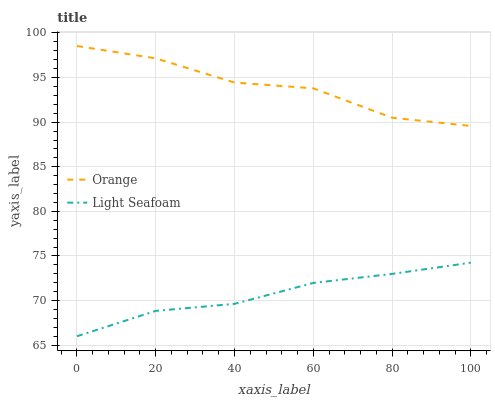Does Light Seafoam have the minimum area under the curve?
Answer yes or no. Yes. Does Orange have the maximum area under the curve?
Answer yes or no. Yes. Does Light Seafoam have the maximum area under the curve?
Answer yes or no. No. Is Light Seafoam the smoothest?
Answer yes or no. Yes. Is Orange the roughest?
Answer yes or no. Yes. Is Light Seafoam the roughest?
Answer yes or no. No. Does Light Seafoam have the lowest value?
Answer yes or no. Yes. Does Orange have the highest value?
Answer yes or no. Yes. Does Light Seafoam have the highest value?
Answer yes or no. No. Is Light Seafoam less than Orange?
Answer yes or no. Yes. Is Orange greater than Light Seafoam?
Answer yes or no. Yes. Does Light Seafoam intersect Orange?
Answer yes or no. No. 